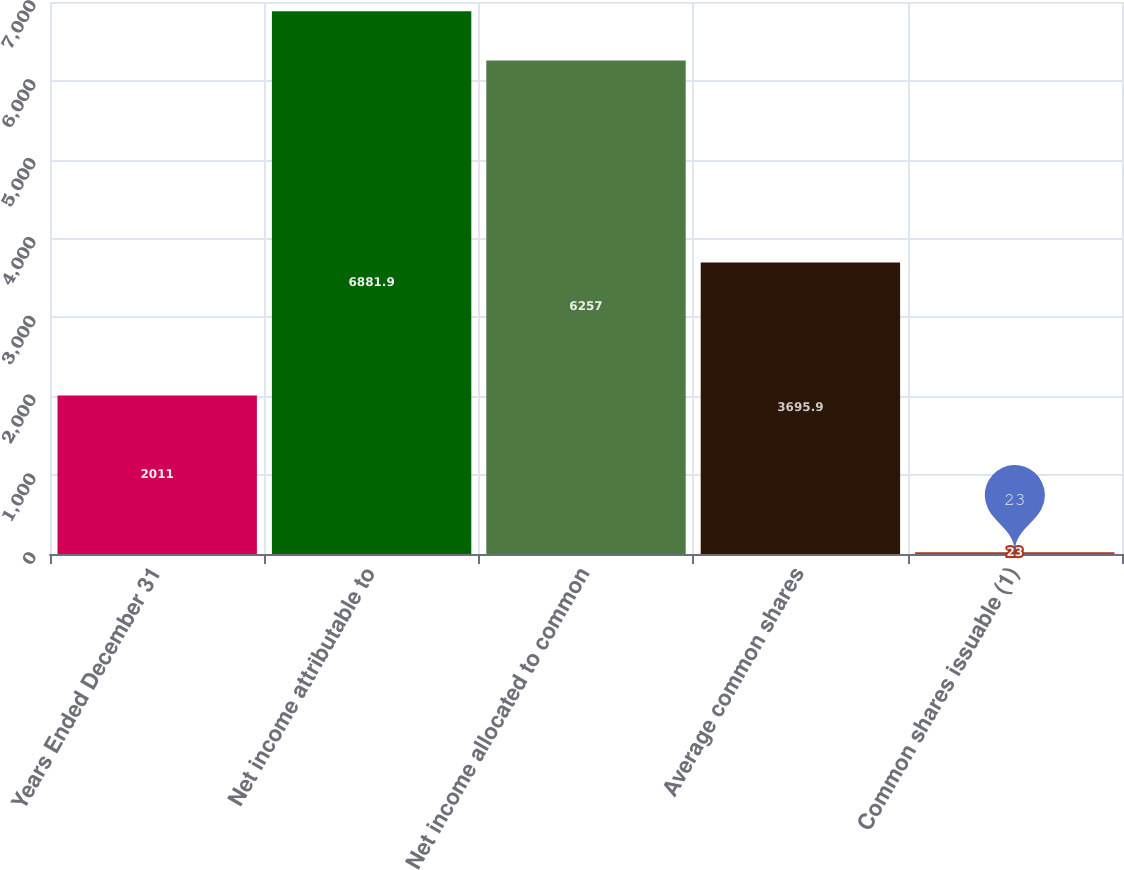Convert chart. <chart><loc_0><loc_0><loc_500><loc_500><bar_chart><fcel>Years Ended December 31<fcel>Net income attributable to<fcel>Net income allocated to common<fcel>Average common shares<fcel>Common shares issuable (1)<nl><fcel>2011<fcel>6881.9<fcel>6257<fcel>3695.9<fcel>23<nl></chart> 